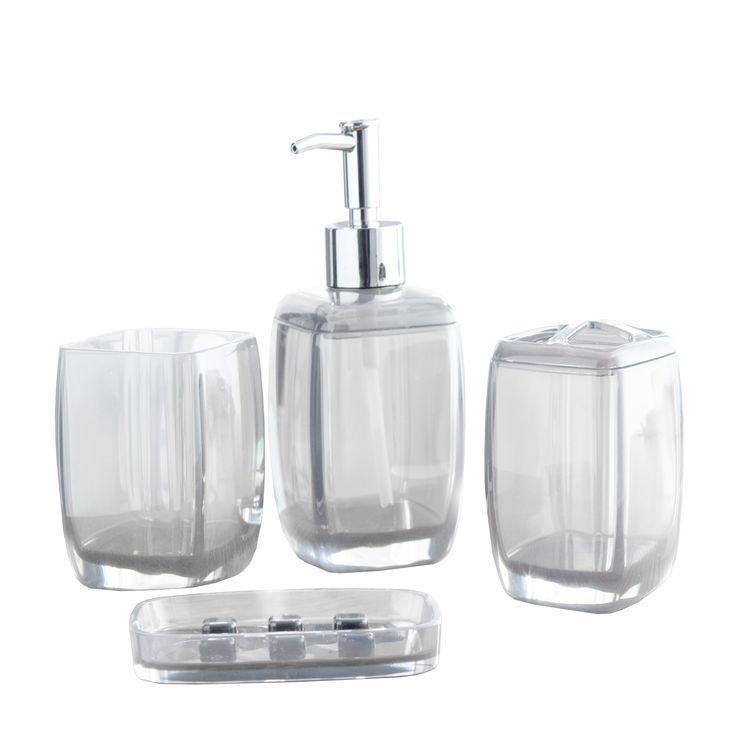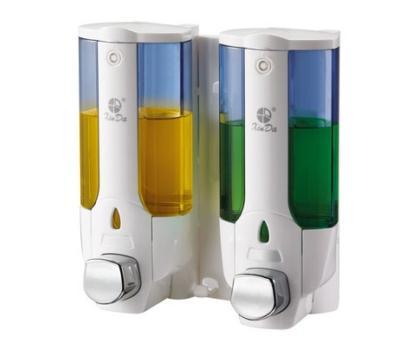The first image is the image on the left, the second image is the image on the right. Given the left and right images, does the statement "At least one of the images shows a dual wall dispenser." hold true? Answer yes or no. Yes. The first image is the image on the left, the second image is the image on the right. For the images shown, is this caption "At least one image is of items that are not wall mounted." true? Answer yes or no. Yes. 